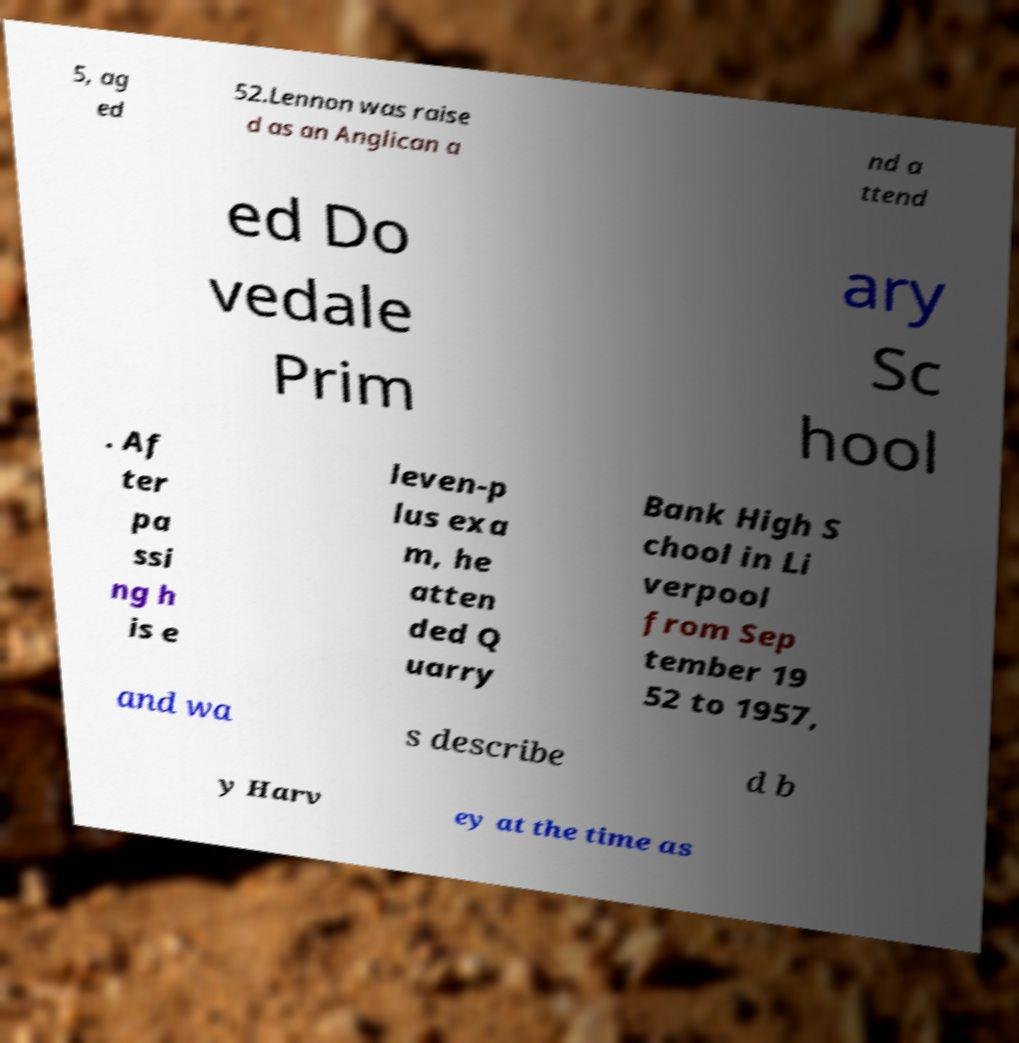Please read and relay the text visible in this image. What does it say? 5, ag ed 52.Lennon was raise d as an Anglican a nd a ttend ed Do vedale Prim ary Sc hool . Af ter pa ssi ng h is e leven-p lus exa m, he atten ded Q uarry Bank High S chool in Li verpool from Sep tember 19 52 to 1957, and wa s describe d b y Harv ey at the time as 